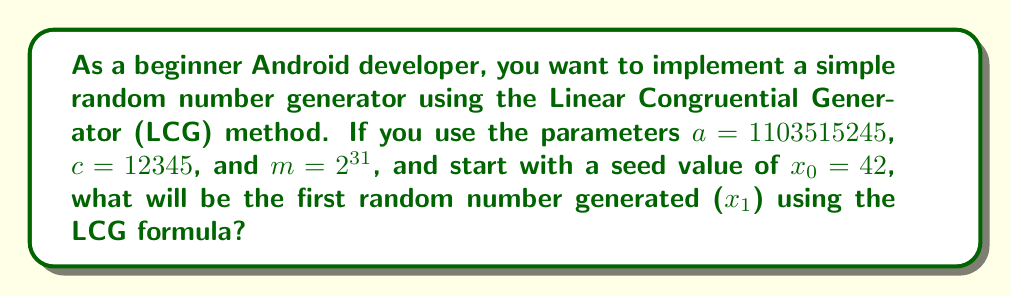Could you help me with this problem? Let's approach this step-by-step:

1) The Linear Congruential Generator (LCG) uses the following formula to generate random numbers:

   $$x_{n+1} = (ax_n + c) \mod m$$

   Where:
   - $x_n$ is the current number
   - $x_{n+1}$ is the next number in the sequence
   - $a$, $c$, and $m$ are constants

2) We are given:
   - $a = 1103515245$
   - $c = 12345$
   - $m = 2^{31} = 2147483648$
   - $x_0 = 42$ (the seed value)

3) Let's substitute these values into the LCG formula to find $x_1$:

   $$x_1 = (1103515245 \cdot 42 + 12345) \mod 2147483648$$

4) First, let's calculate the multiplication:
   
   $$1103515245 \cdot 42 = 46347639290$$

5) Now add $c$:

   $$46347639290 + 12345 = 46347651635$$

6) Finally, we need to take the modulus with $m$:

   $$46347651635 \mod 2147483648 = 1250496027$$

Therefore, the first random number generated ($x_1$) will be 1250496027.
Answer: 1250496027 